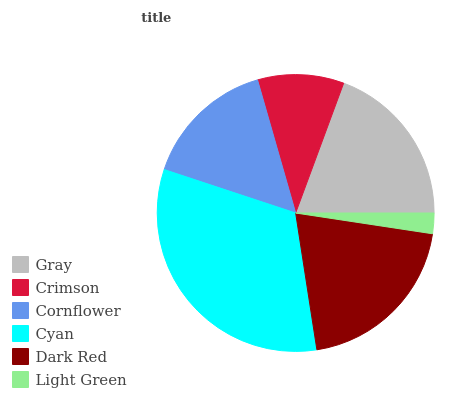Is Light Green the minimum?
Answer yes or no. Yes. Is Cyan the maximum?
Answer yes or no. Yes. Is Crimson the minimum?
Answer yes or no. No. Is Crimson the maximum?
Answer yes or no. No. Is Gray greater than Crimson?
Answer yes or no. Yes. Is Crimson less than Gray?
Answer yes or no. Yes. Is Crimson greater than Gray?
Answer yes or no. No. Is Gray less than Crimson?
Answer yes or no. No. Is Gray the high median?
Answer yes or no. Yes. Is Cornflower the low median?
Answer yes or no. Yes. Is Dark Red the high median?
Answer yes or no. No. Is Gray the low median?
Answer yes or no. No. 